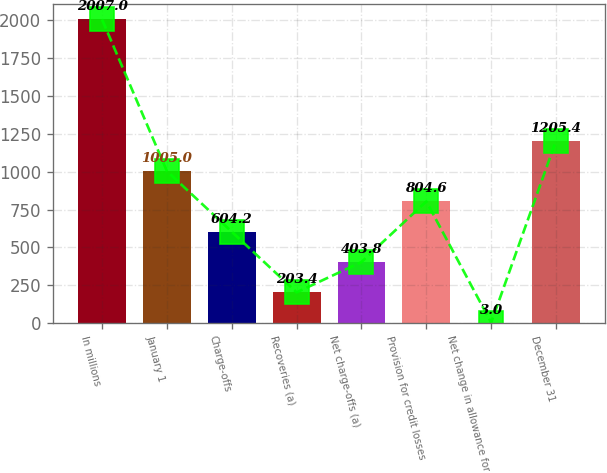<chart> <loc_0><loc_0><loc_500><loc_500><bar_chart><fcel>In millions<fcel>January 1<fcel>Charge-offs<fcel>Recoveries (a)<fcel>Net charge-offs (a)<fcel>Provision for credit losses<fcel>Net change in allowance for<fcel>December 31<nl><fcel>2007<fcel>1005<fcel>604.2<fcel>203.4<fcel>403.8<fcel>804.6<fcel>3<fcel>1205.4<nl></chart> 